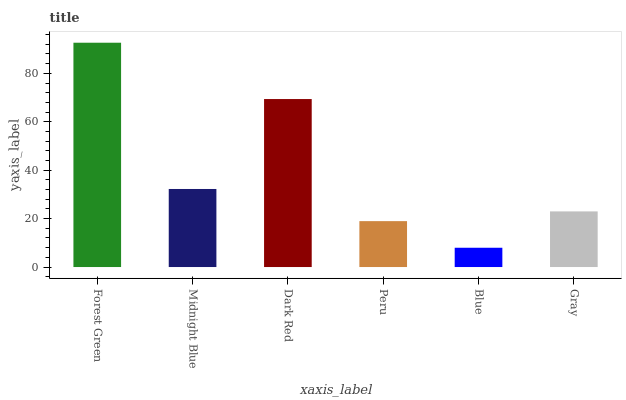Is Blue the minimum?
Answer yes or no. Yes. Is Forest Green the maximum?
Answer yes or no. Yes. Is Midnight Blue the minimum?
Answer yes or no. No. Is Midnight Blue the maximum?
Answer yes or no. No. Is Forest Green greater than Midnight Blue?
Answer yes or no. Yes. Is Midnight Blue less than Forest Green?
Answer yes or no. Yes. Is Midnight Blue greater than Forest Green?
Answer yes or no. No. Is Forest Green less than Midnight Blue?
Answer yes or no. No. Is Midnight Blue the high median?
Answer yes or no. Yes. Is Gray the low median?
Answer yes or no. Yes. Is Forest Green the high median?
Answer yes or no. No. Is Peru the low median?
Answer yes or no. No. 